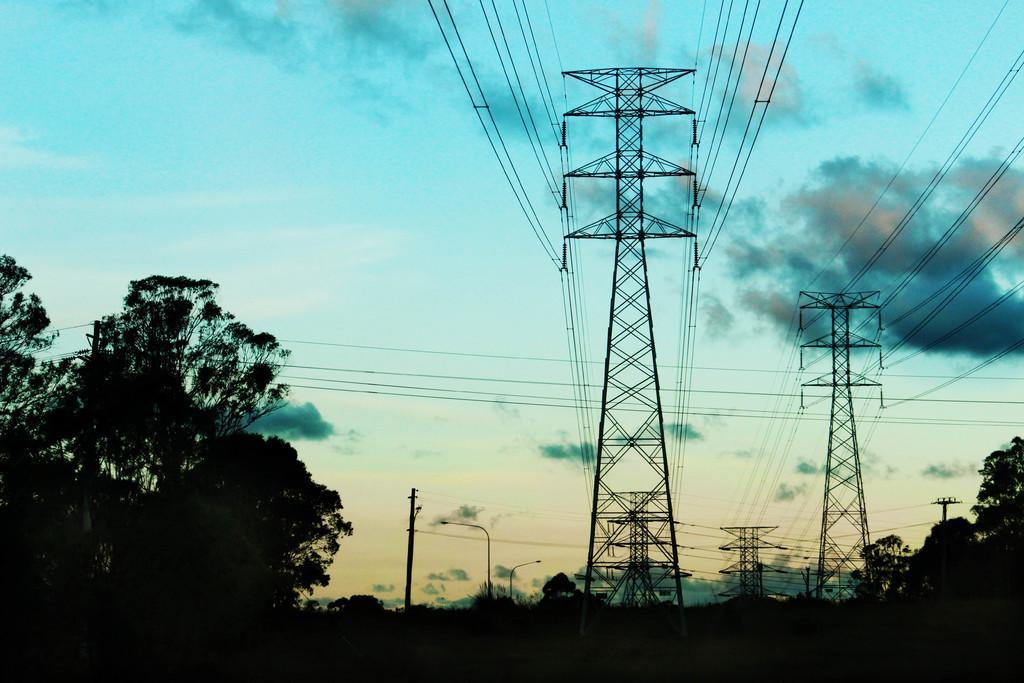Could you give a brief overview of what you see in this image? This picture is taken from outside of the city. In this image, on the right side, we can see some trees and plants. On the left side, we can also see some trees and plants. In the middle of the image, we can see electric pole, street lights, electric wires. At the top, we can see a sky which is cloudy, at the bottom, we can see black color. 